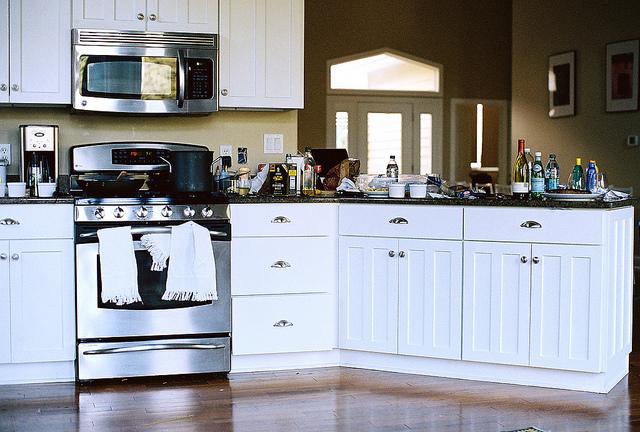Is this room clean?
Concise answer only. No. How many bottles are there on the counter?
Answer briefly. 7. How many towels are there?
Give a very brief answer. 2. How many sockets are shown?
Keep it brief. 2. 